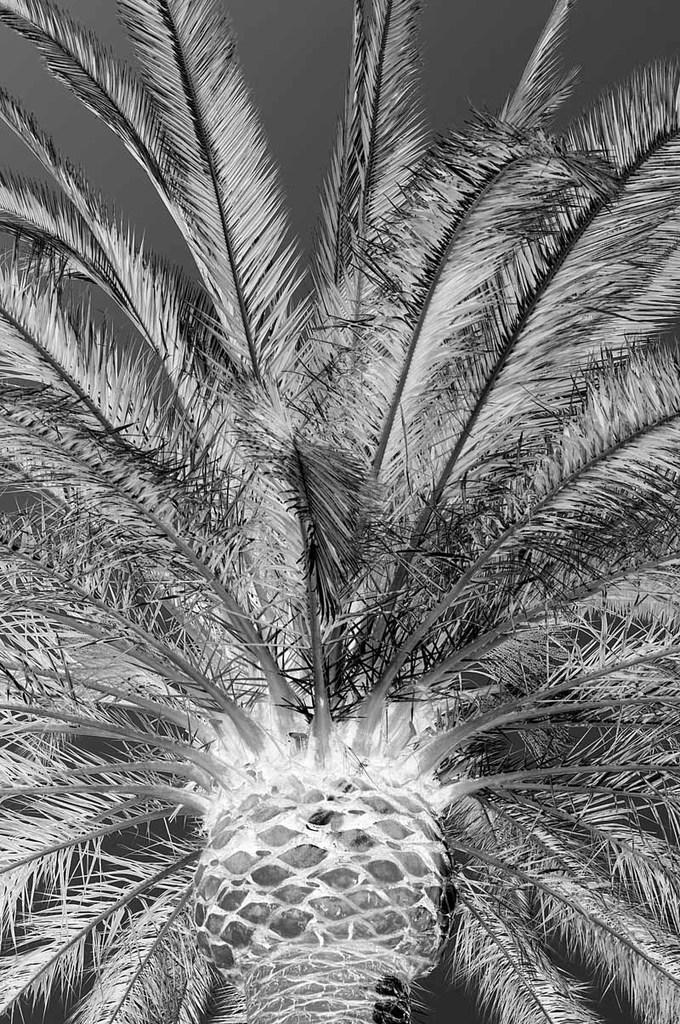In one or two sentences, can you explain what this image depicts? This is a black and white image. In the image there is a tree with leaves and also there is a trunk. 